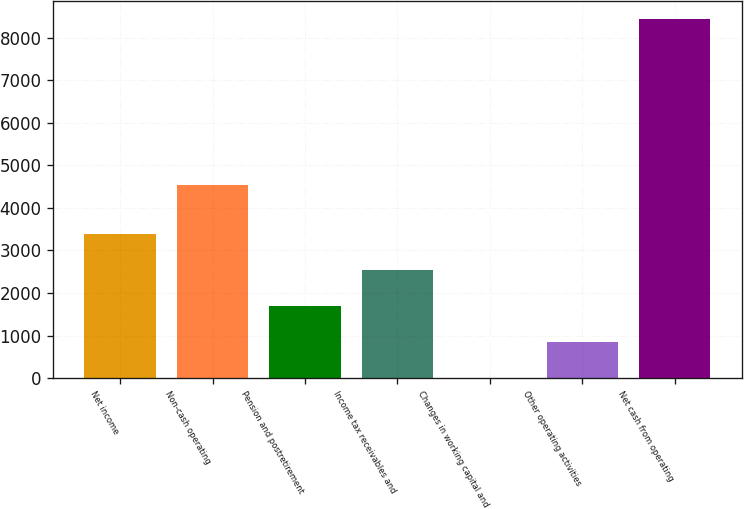Convert chart. <chart><loc_0><loc_0><loc_500><loc_500><bar_chart><fcel>Net income<fcel>Non-cash operating<fcel>Pension and postretirement<fcel>Income tax receivables and<fcel>Changes in working capital and<fcel>Other operating activities<fcel>Net cash from operating<nl><fcel>3374<fcel>4539<fcel>1690<fcel>2532<fcel>6<fcel>848<fcel>8426<nl></chart> 